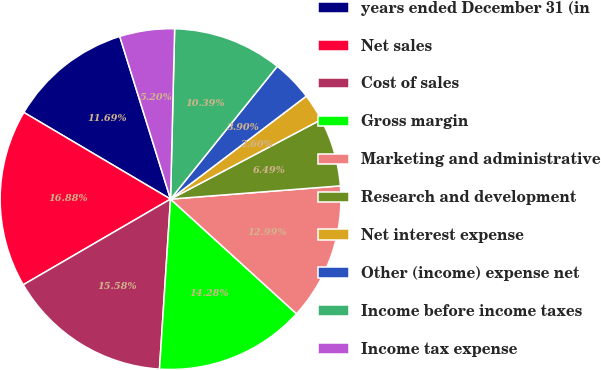Convert chart. <chart><loc_0><loc_0><loc_500><loc_500><pie_chart><fcel>years ended December 31 (in<fcel>Net sales<fcel>Cost of sales<fcel>Gross margin<fcel>Marketing and administrative<fcel>Research and development<fcel>Net interest expense<fcel>Other (income) expense net<fcel>Income before income taxes<fcel>Income tax expense<nl><fcel>11.69%<fcel>16.88%<fcel>15.58%<fcel>14.28%<fcel>12.99%<fcel>6.49%<fcel>2.6%<fcel>3.9%<fcel>10.39%<fcel>5.2%<nl></chart> 